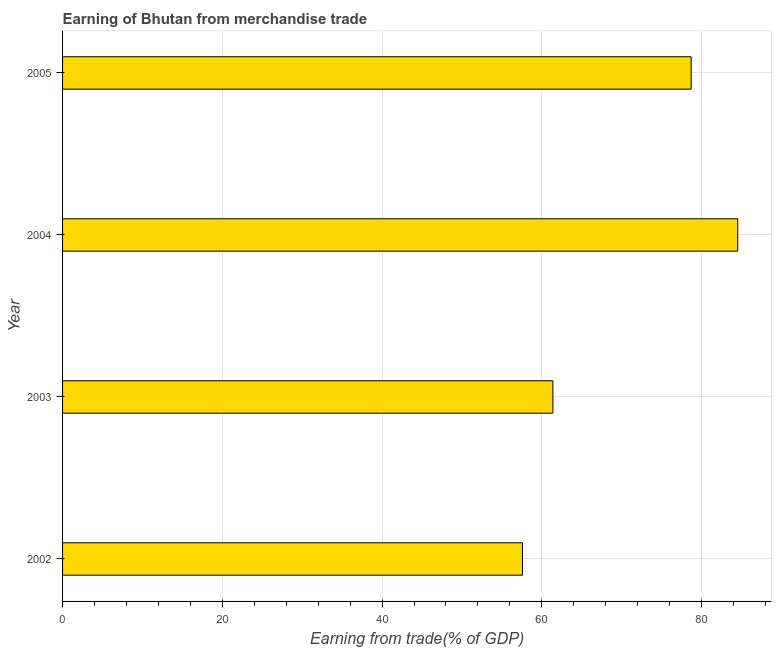Does the graph contain any zero values?
Give a very brief answer. No. Does the graph contain grids?
Provide a short and direct response. Yes. What is the title of the graph?
Offer a very short reply. Earning of Bhutan from merchandise trade. What is the label or title of the X-axis?
Ensure brevity in your answer.  Earning from trade(% of GDP). What is the label or title of the Y-axis?
Your answer should be very brief. Year. What is the earning from merchandise trade in 2002?
Offer a terse response. 57.58. Across all years, what is the maximum earning from merchandise trade?
Make the answer very short. 84.53. Across all years, what is the minimum earning from merchandise trade?
Give a very brief answer. 57.58. In which year was the earning from merchandise trade maximum?
Offer a terse response. 2004. What is the sum of the earning from merchandise trade?
Provide a short and direct response. 282.21. What is the difference between the earning from merchandise trade in 2004 and 2005?
Offer a terse response. 5.83. What is the average earning from merchandise trade per year?
Your response must be concise. 70.55. What is the median earning from merchandise trade?
Offer a very short reply. 70.05. Do a majority of the years between 2002 and 2003 (inclusive) have earning from merchandise trade greater than 36 %?
Offer a terse response. Yes. What is the ratio of the earning from merchandise trade in 2002 to that in 2005?
Offer a terse response. 0.73. What is the difference between the highest and the second highest earning from merchandise trade?
Ensure brevity in your answer.  5.83. What is the difference between the highest and the lowest earning from merchandise trade?
Your response must be concise. 26.95. Are all the bars in the graph horizontal?
Offer a very short reply. Yes. What is the difference between two consecutive major ticks on the X-axis?
Provide a short and direct response. 20. What is the Earning from trade(% of GDP) of 2002?
Keep it short and to the point. 57.58. What is the Earning from trade(% of GDP) in 2003?
Your answer should be compact. 61.39. What is the Earning from trade(% of GDP) of 2004?
Provide a succinct answer. 84.53. What is the Earning from trade(% of GDP) of 2005?
Ensure brevity in your answer.  78.71. What is the difference between the Earning from trade(% of GDP) in 2002 and 2003?
Ensure brevity in your answer.  -3.81. What is the difference between the Earning from trade(% of GDP) in 2002 and 2004?
Ensure brevity in your answer.  -26.95. What is the difference between the Earning from trade(% of GDP) in 2002 and 2005?
Offer a very short reply. -21.12. What is the difference between the Earning from trade(% of GDP) in 2003 and 2004?
Offer a terse response. -23.14. What is the difference between the Earning from trade(% of GDP) in 2003 and 2005?
Give a very brief answer. -17.31. What is the difference between the Earning from trade(% of GDP) in 2004 and 2005?
Keep it short and to the point. 5.83. What is the ratio of the Earning from trade(% of GDP) in 2002 to that in 2003?
Provide a short and direct response. 0.94. What is the ratio of the Earning from trade(% of GDP) in 2002 to that in 2004?
Give a very brief answer. 0.68. What is the ratio of the Earning from trade(% of GDP) in 2002 to that in 2005?
Make the answer very short. 0.73. What is the ratio of the Earning from trade(% of GDP) in 2003 to that in 2004?
Your answer should be compact. 0.73. What is the ratio of the Earning from trade(% of GDP) in 2003 to that in 2005?
Make the answer very short. 0.78. What is the ratio of the Earning from trade(% of GDP) in 2004 to that in 2005?
Your answer should be very brief. 1.07. 